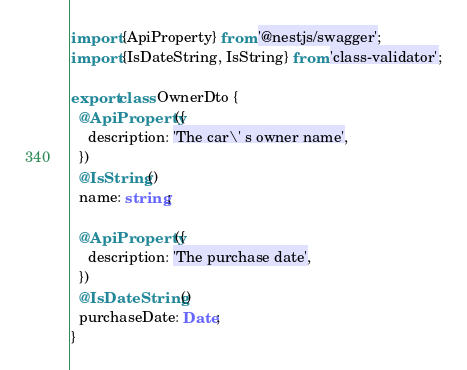<code> <loc_0><loc_0><loc_500><loc_500><_TypeScript_>import {ApiProperty} from '@nestjs/swagger';
import {IsDateString, IsString} from 'class-validator';

export class OwnerDto {
  @ApiProperty({
    description: 'The car\' s owner name',
  })
  @IsString()
  name: string;

  @ApiProperty({
    description: 'The purchase date',
  })
  @IsDateString()
  purchaseDate: Date;
}</code> 